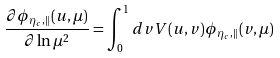<formula> <loc_0><loc_0><loc_500><loc_500>\frac { \partial \phi _ { \eta _ { c } , \| } ( u , \mu ) } { \partial \ln \mu ^ { 2 } } = \int _ { 0 } ^ { 1 } d v V ( u , v ) \phi _ { \eta _ { c } , \| } ( v , \mu )</formula> 